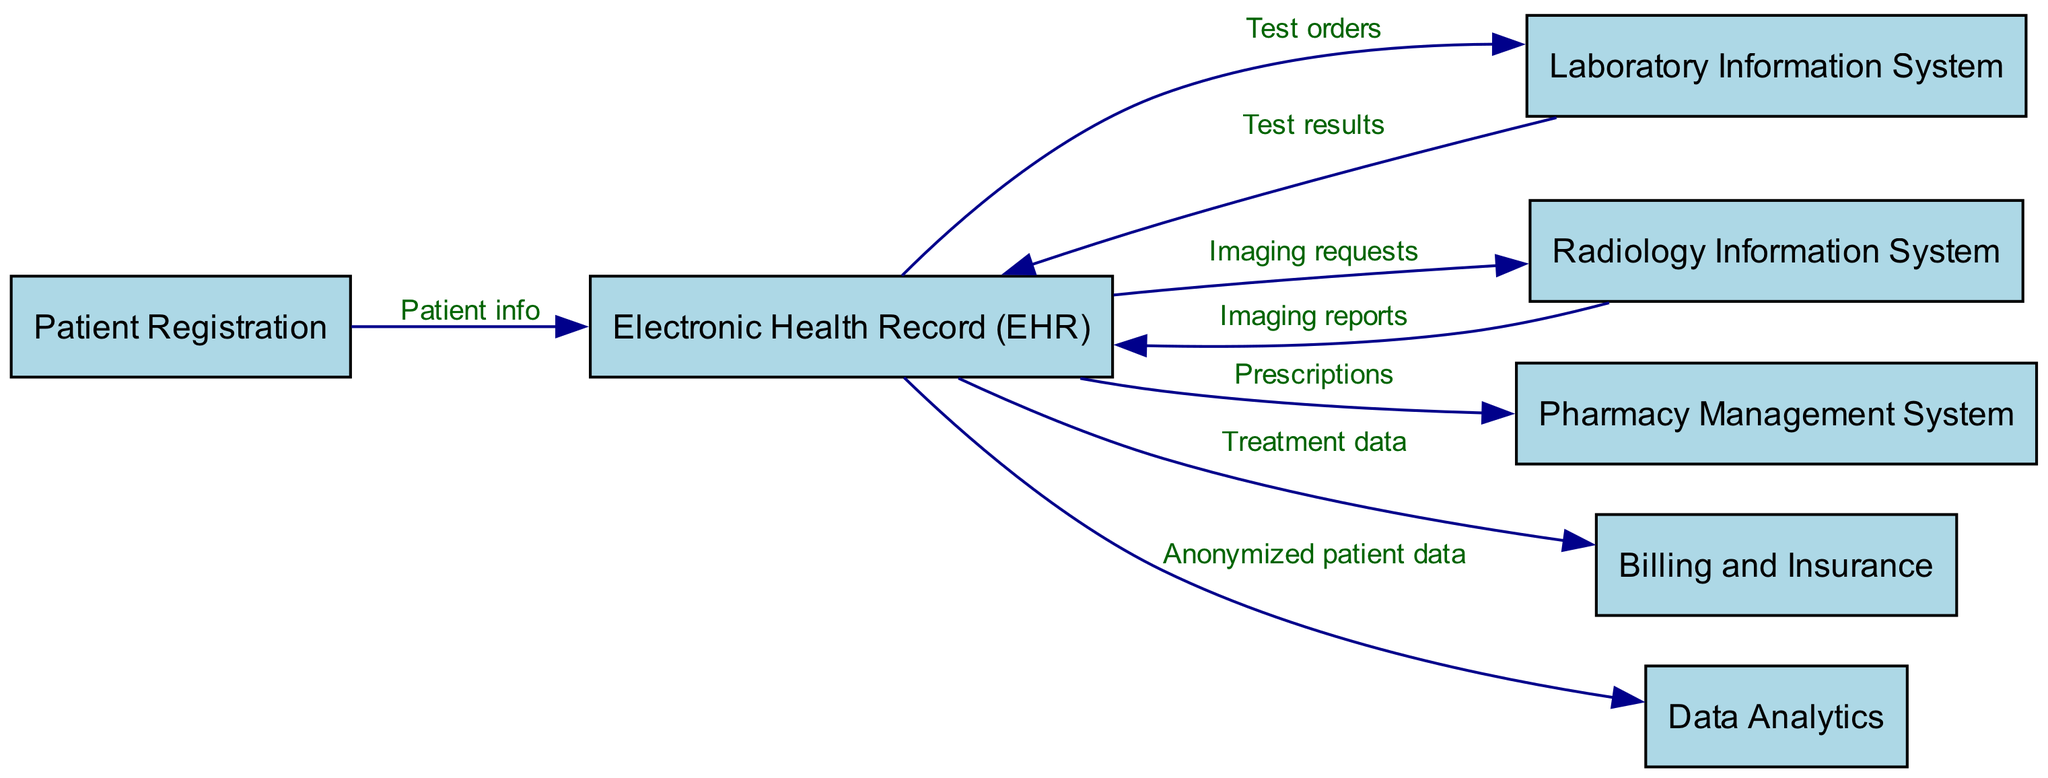What is the starting point of the patient data flow? The diagram indicates that the flow of patient data begins with the "Patient Registration" node, as it is the first node listed and has outgoing edges leading to other nodes.
Answer: Patient Registration How many total nodes are in the diagram? By counting the unique entities (nodes) listed, there are a total of seven distinct nodes within the diagram.
Answer: 7 Which system receives "Test results"? The "Laboratory Information System" sends "Test results" to the "Electronic Health Record (EHR)" as indicated by the directed edge in the diagram.
Answer: Electronic Health Record (EHR) What type of information flows from the Electronic Health Record to Billing and Insurance? The edge labeled between the "Electronic Health Record (EHR)" and "Billing and Insurance" shows that "Treatment data" flows to the billing system, which is specifically stated in the diagram.
Answer: Treatment data Identify the last destination in the patient data flow. The final node that receives data from the "Electronic Health Record (EHR)" is "Data Analytics," making it the last destination in this flow.
Answer: Data Analytics How many edges are connected to the Electronic Health Record? There are four outgoing edges leading from the "Electronic Health Record (EHR)" to other systems: "Laboratory Information System," "Radiology Information System," "Pharmacy Management System," and "Billing and Insurance." This results in four connections.
Answer: 4 What information does the Laboratory Information System send back to the Electronic Health Record? The directed edge indicates that the "Laboratory Information System" sends "Test results" back to the "Electronic Health Record (EHR)," as detailed in the edge label.
Answer: Test results Which two systems receive information directly from the Electronic Health Record about imaging? The "Radiology Information System" and "Pharmacy Management System" both receive information from the "Electronic Health Record (EHR)" related to imaging requests and prescriptions, respectively, identified by their outgoing edges.
Answer: Radiology Information System, Pharmacy Management System 